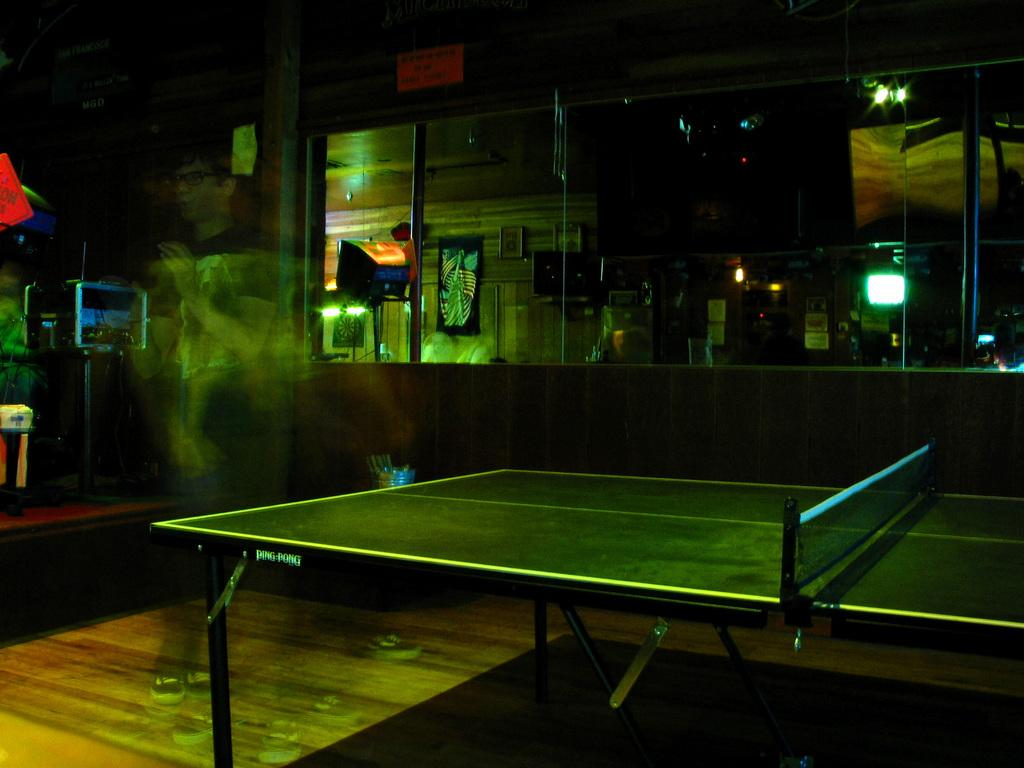What is the main object in the image? There is a table in the image. What is unique about the table? The table has a net attached to it. What can be seen in the background of the image? There is a framed glass wall and lights visible in the background, and describe the objects present. What else can be seen on the floor in the background of the image? There are other objects on the floor in the background of the image. Can you see any stars in the image? There are no stars visible in the image. Are there any bats flying around in the image? There are no bats present in the image. 